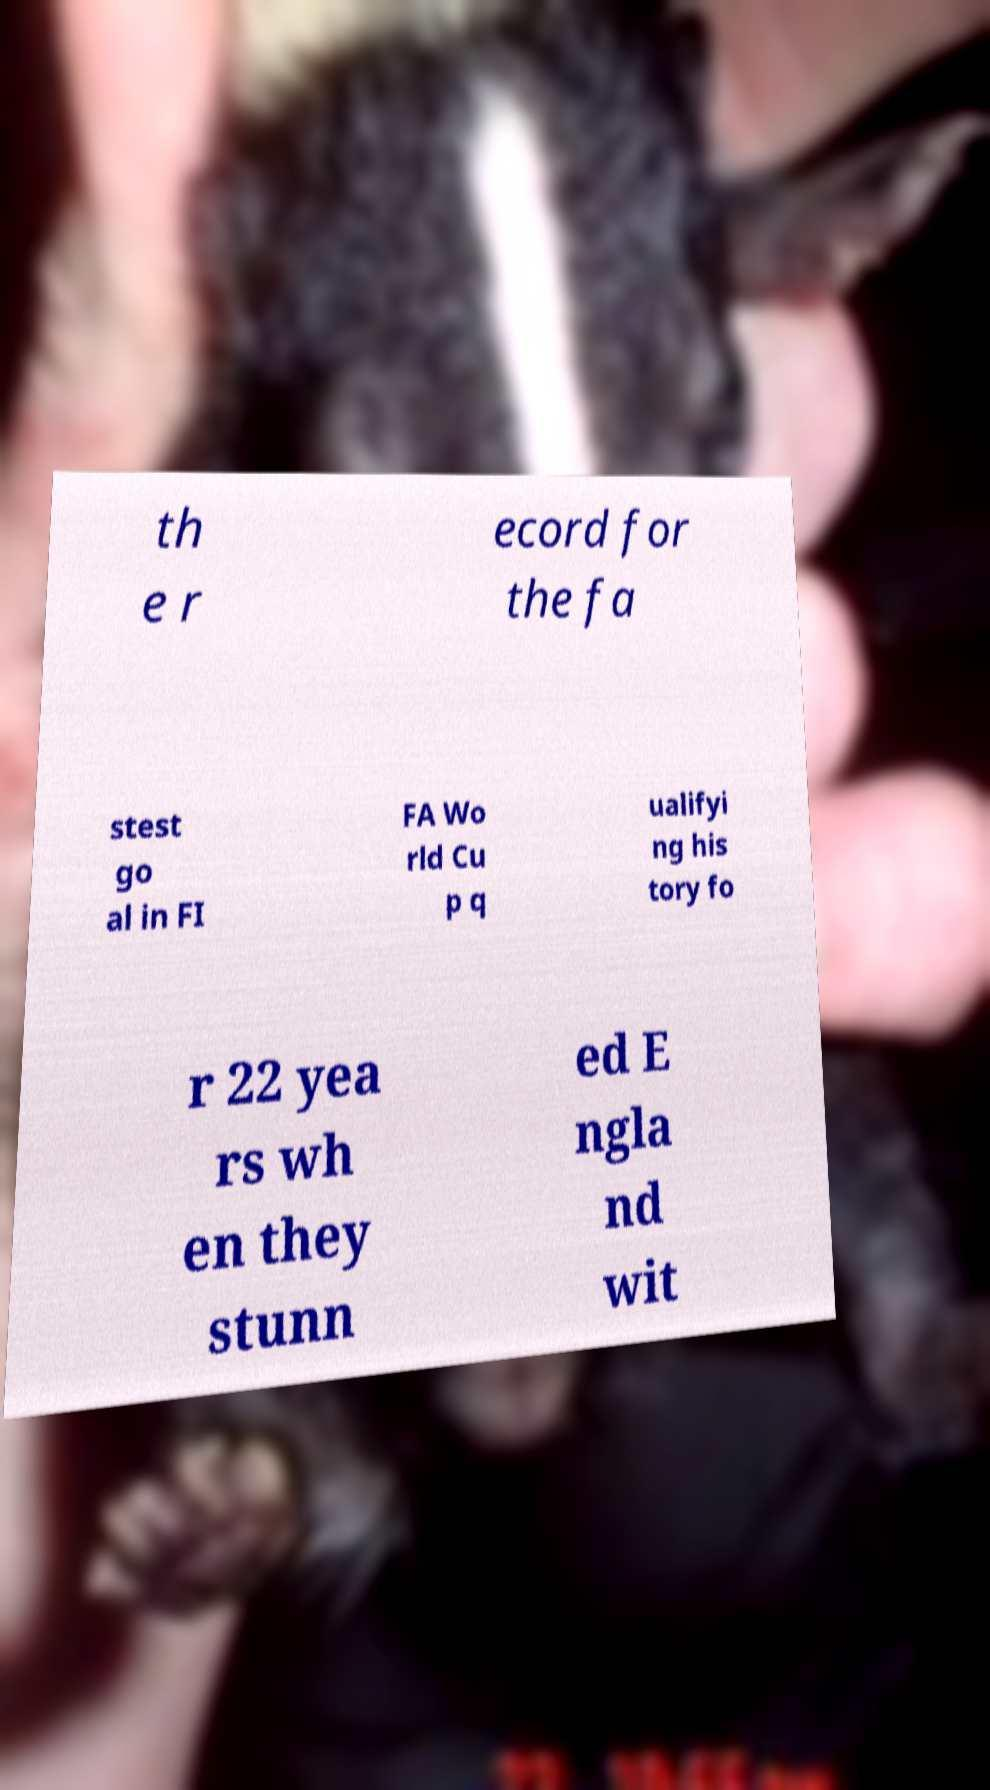Please read and relay the text visible in this image. What does it say? th e r ecord for the fa stest go al in FI FA Wo rld Cu p q ualifyi ng his tory fo r 22 yea rs wh en they stunn ed E ngla nd wit 